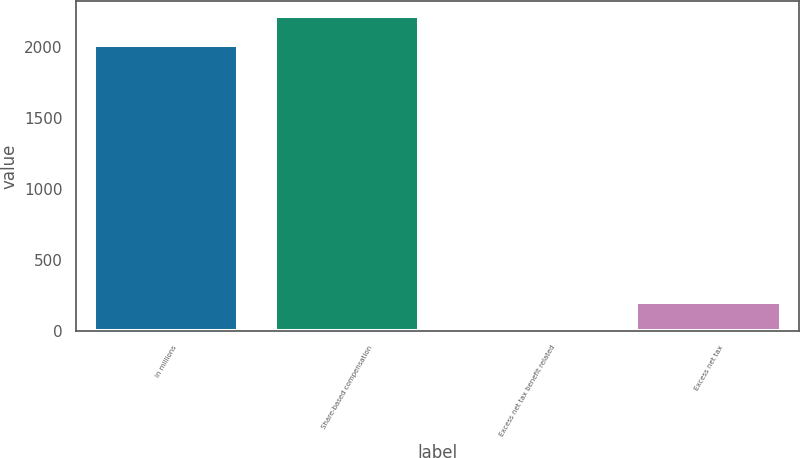Convert chart to OTSL. <chart><loc_0><loc_0><loc_500><loc_500><bar_chart><fcel>in millions<fcel>Share-based compensation<fcel>Excess net tax benefit related<fcel>Excess net tax<nl><fcel>2013<fcel>2216.6<fcel>3<fcel>206.6<nl></chart> 